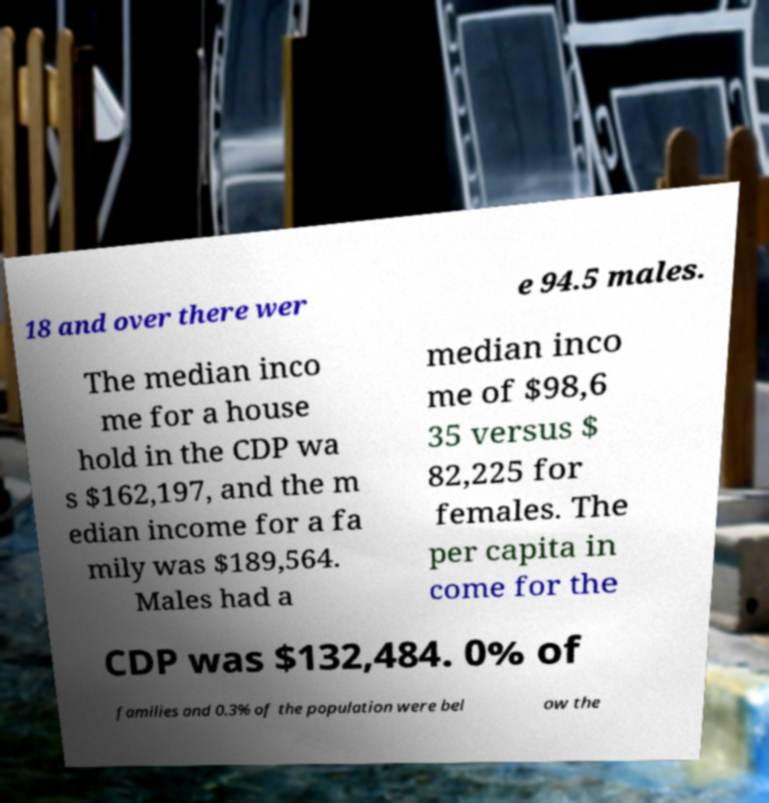Can you read and provide the text displayed in the image?This photo seems to have some interesting text. Can you extract and type it out for me? 18 and over there wer e 94.5 males. The median inco me for a house hold in the CDP wa s $162,197, and the m edian income for a fa mily was $189,564. Males had a median inco me of $98,6 35 versus $ 82,225 for females. The per capita in come for the CDP was $132,484. 0% of families and 0.3% of the population were bel ow the 